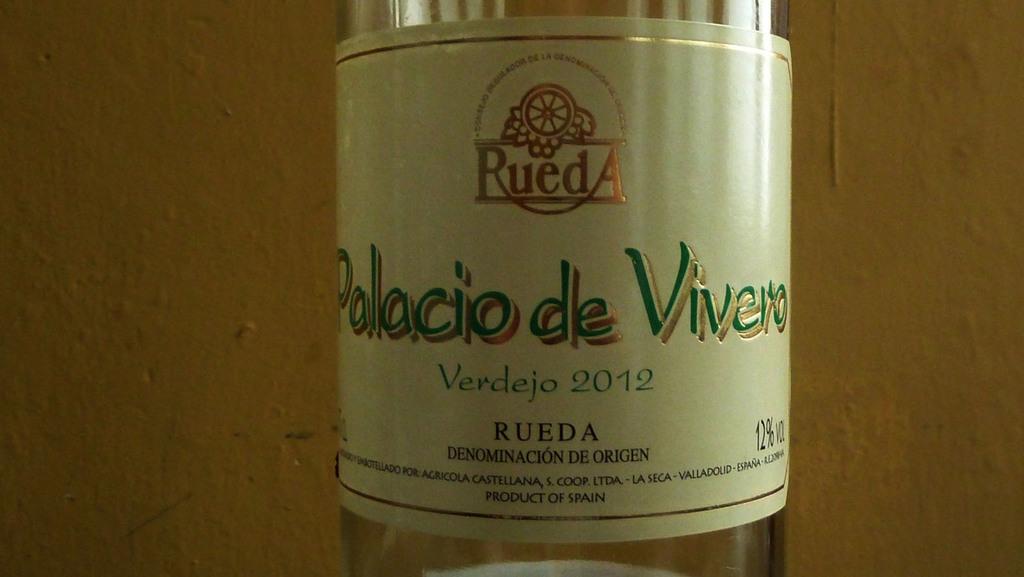What brand of alcohol is this?
Your answer should be compact. Rueda. What is the year of this wine?
Give a very brief answer. 2012. 